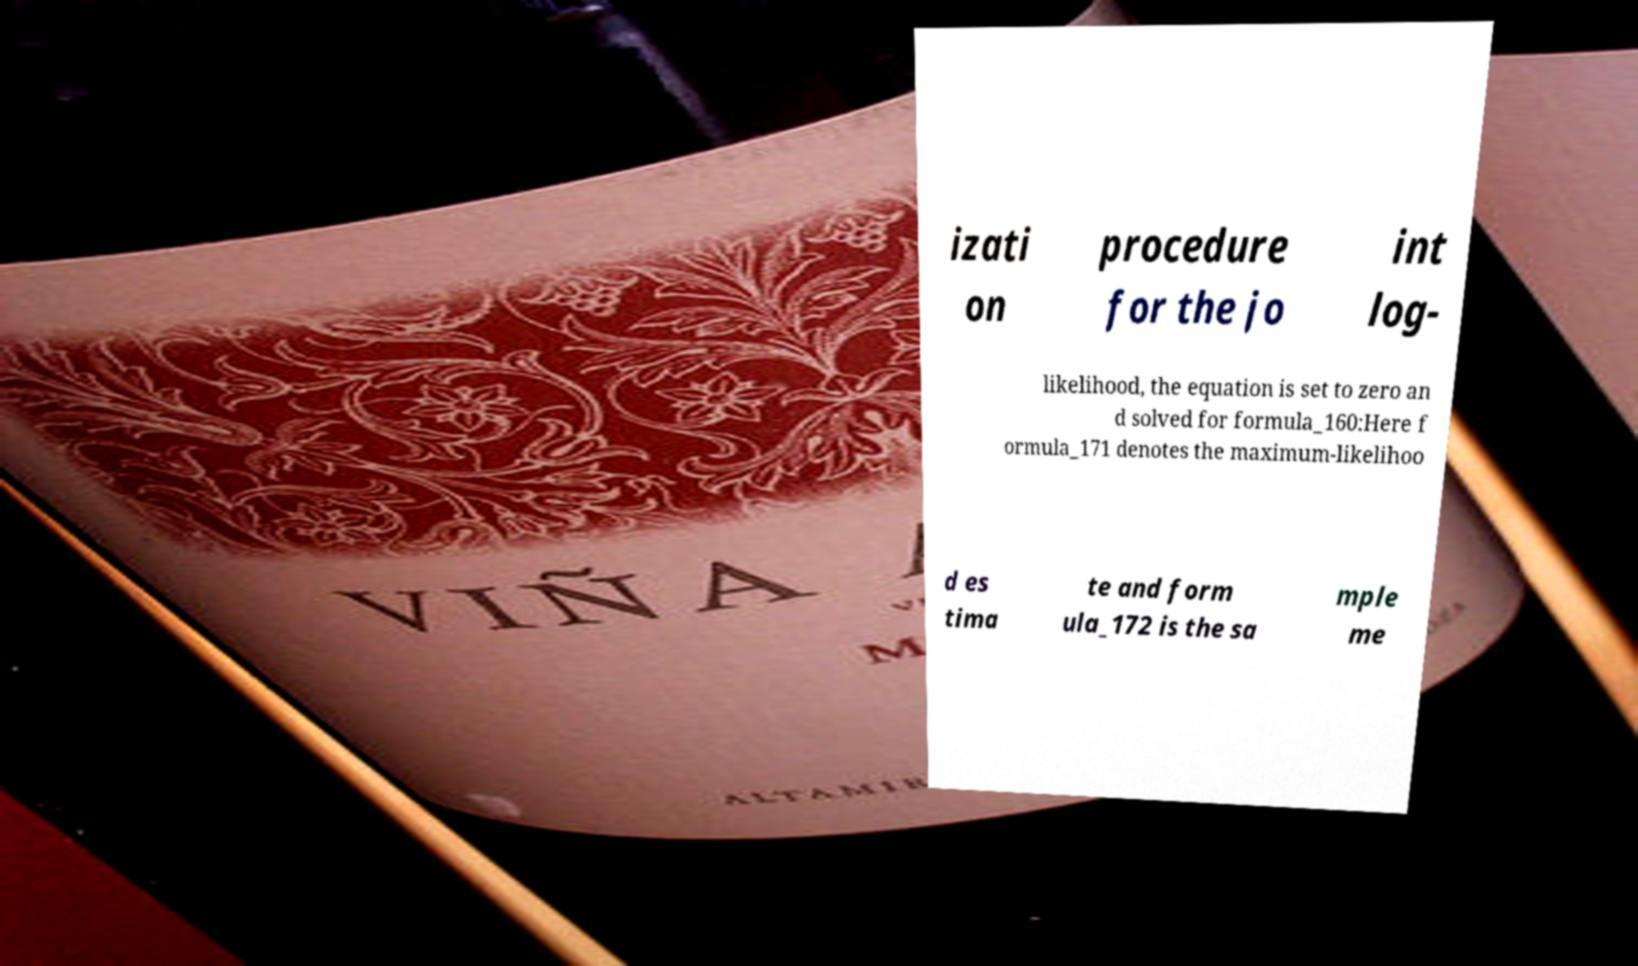For documentation purposes, I need the text within this image transcribed. Could you provide that? izati on procedure for the jo int log- likelihood, the equation is set to zero an d solved for formula_160:Here f ormula_171 denotes the maximum-likelihoo d es tima te and form ula_172 is the sa mple me 